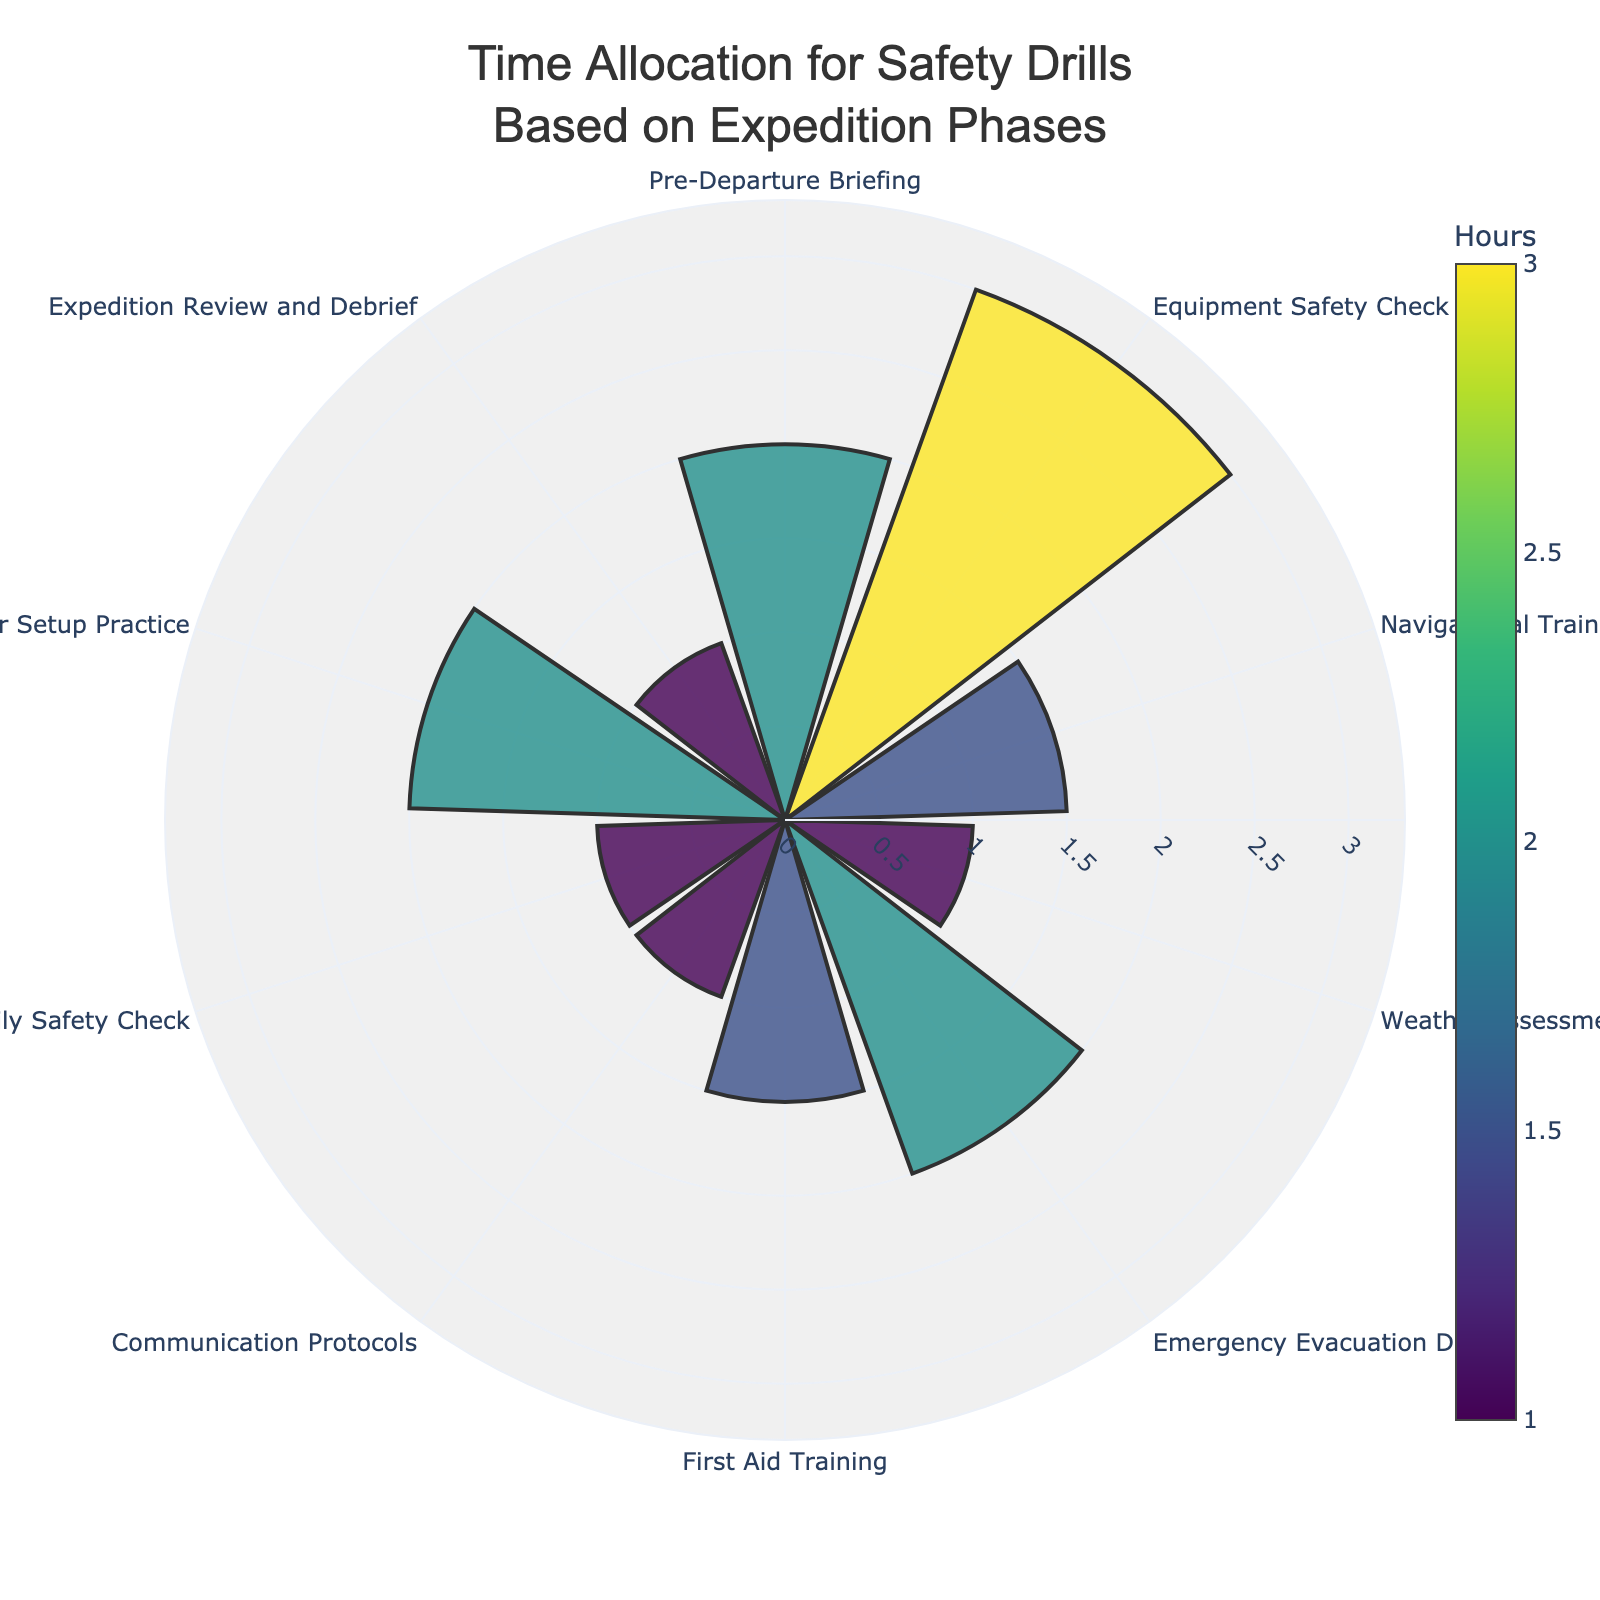What's the title of the figure? The title of the figure can be found at the top, usually in a larger font size, and it provides a summary of what the chart represents.
Answer: Time Allocation for Safety Drills Based on Expedition Phases How many phases are included in the figure? To determine the number of phases, count the named segments in the polar area chart.
Answer: 10 Which phase has the highest time allocation? Identify the segment with the largest radial length.
Answer: Equipment Safety Check What's the combined time allocation for Emergency Evacuation Drill and Shelter Setup Practice? Add the time allocations for both segments. Emergency Evacuation Drill is 2 hours and Shelter Setup Practice is 2 hours.
Answer: 4 hours Which phase has the lowest time allocation? Locate the segment with the smallest radial length.
Answer: Daily Safety Check What's the difference in time allocation between Pre-Departure Briefing and Daily Safety Check? Subtract the time allocation of the Daily Safety Check from that of the Pre-Departure Briefing. Pre-Departure Briefing is 2 hours and Daily Safety Check is 1 hour.
Answer: 1 hour Which phase is allocated twice as much time as Navigational Training? Find the segment whose time allocation is double that of Navigational Training. Navigational Training is 1.5 hours, so the phase should be allocated 3 hours.
Answer: Equipment Safety Check Are there any phases with identical time allocations? If so, which ones? Look for segments with the same radial length.
Answer: Pre-Departure Briefing, Emergency Evacuation Drill, and Shelter Setup Practice (each 2 hours); Navigational Training and First Aid Training (each 1.5 hours); Weather Assessment and Communication Protocols (each 1 hour) What's the average time allocation per phase? Calculate the sum of all time allocations and divide by the number of phases. (2 + 3 + 1.5 + 1 + 2 + 1.5 + 1 + 1 + 2 + 1) / 10 = 16 / 10
Answer: 1.6 hours 